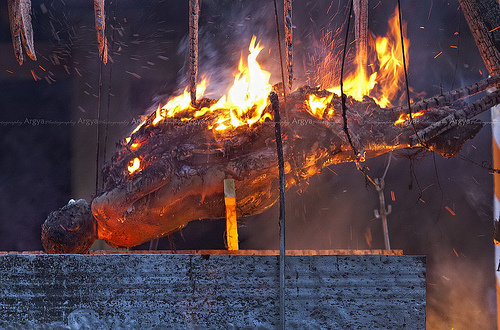<image>
Can you confirm if the fire is in front of the man? No. The fire is not in front of the man. The spatial positioning shows a different relationship between these objects. 